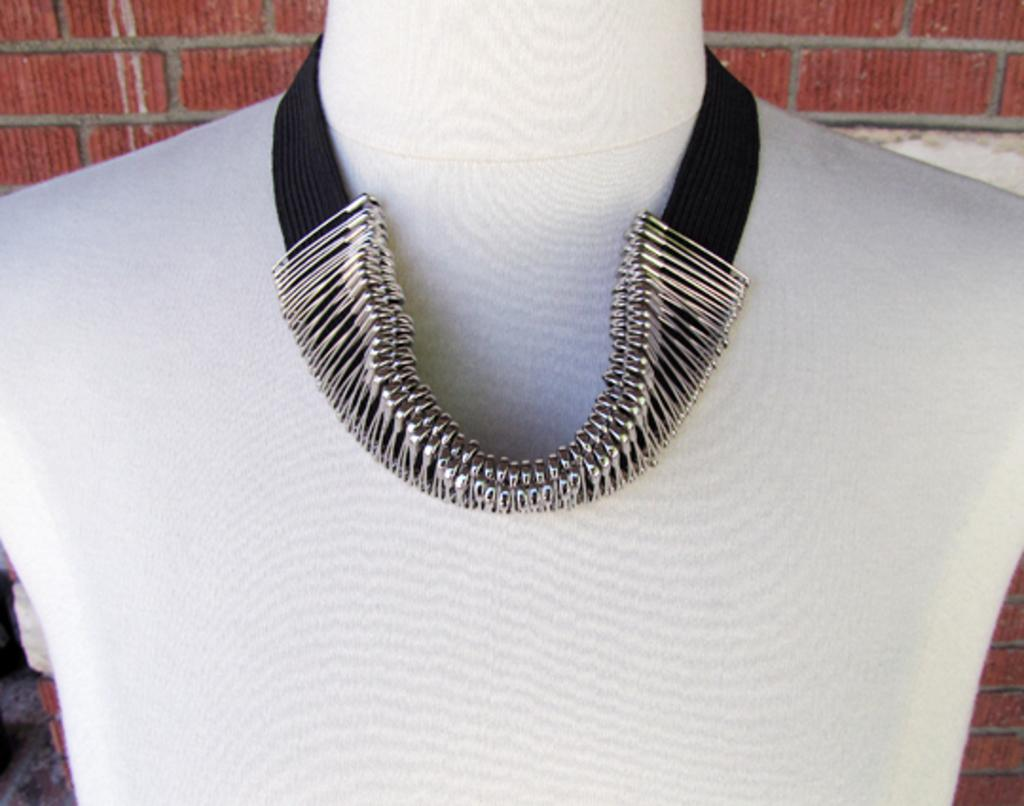What is the main subject of the picture? The main subject of the picture is an artificial human being. What is attached to the artificial human being? The artificial human being has a chain on it. What can be seen in the background of the picture? There is a wall in the background of the picture. What type of celery is being served as a side dish with the meal in the image? There is no meal or celery present in the image; it features an artificial human being with a chain and a wall in the background. 